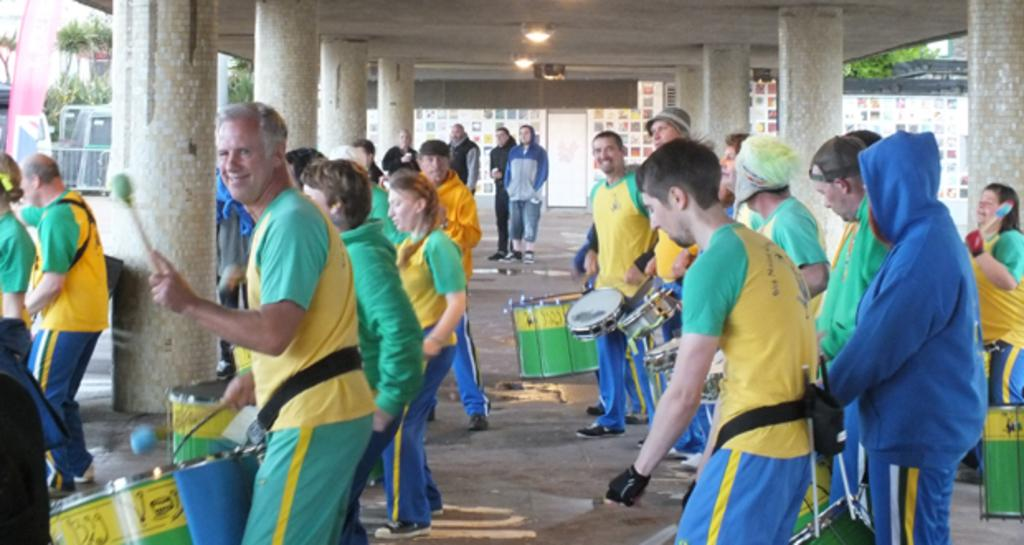How many people are in the image? There is a group of people in the image. What are some of the people doing in the image? Some people are playing drums. What can be seen in the background of the image? There are pillars, lights, and trees in the background of the image. What type of chicken is being played by the person in the image? There is no chicken present in the image, and no one is playing a chicken. Who is the creator of the guitar being played in the image? There is no guitar present in the image, so it is not possible to determine who the creator of the guitar might be. 